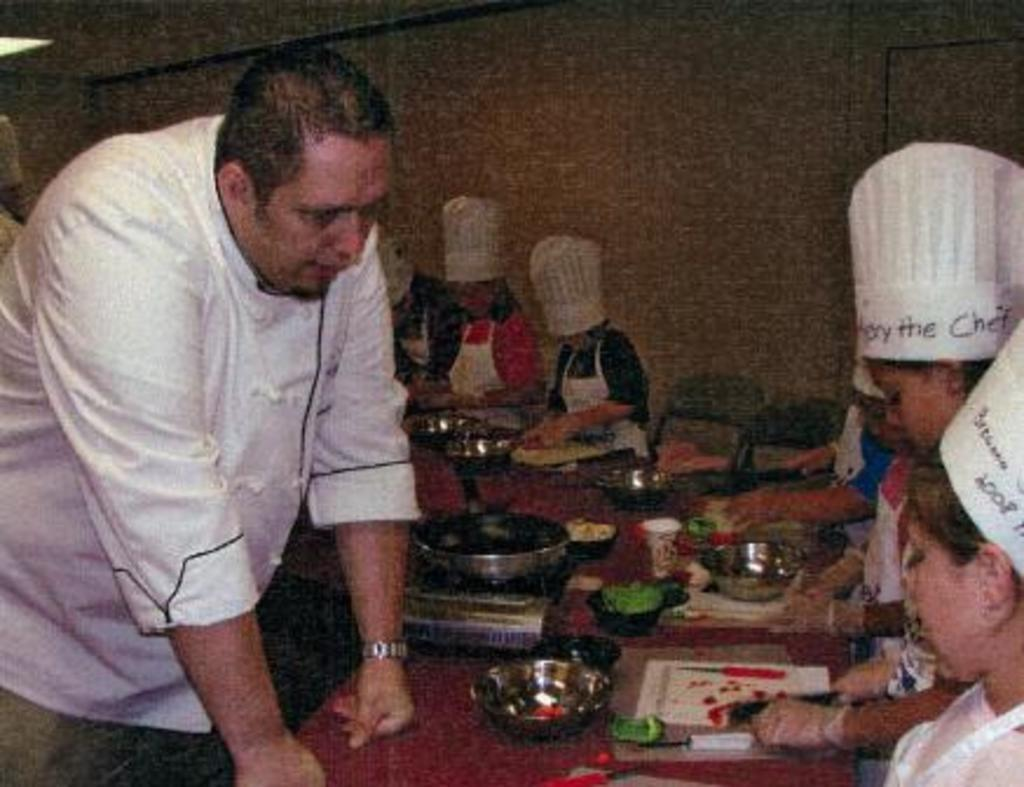Who or what can be seen in the image? There are people in the image. What objects are present on the table in the image? There are objects on the table, including a pan and bowls. What type of background can be seen in the image? There is a wall visible in the image. What is providing illumination in the image? There is a light source in the image. What type of birds can be seen at the zoo in the image? There is no zoo or birds present in the image. What kind of feast is being prepared on the table in the image? There is no feast being prepared on the table in the image; only a pan and bowls are visible. 